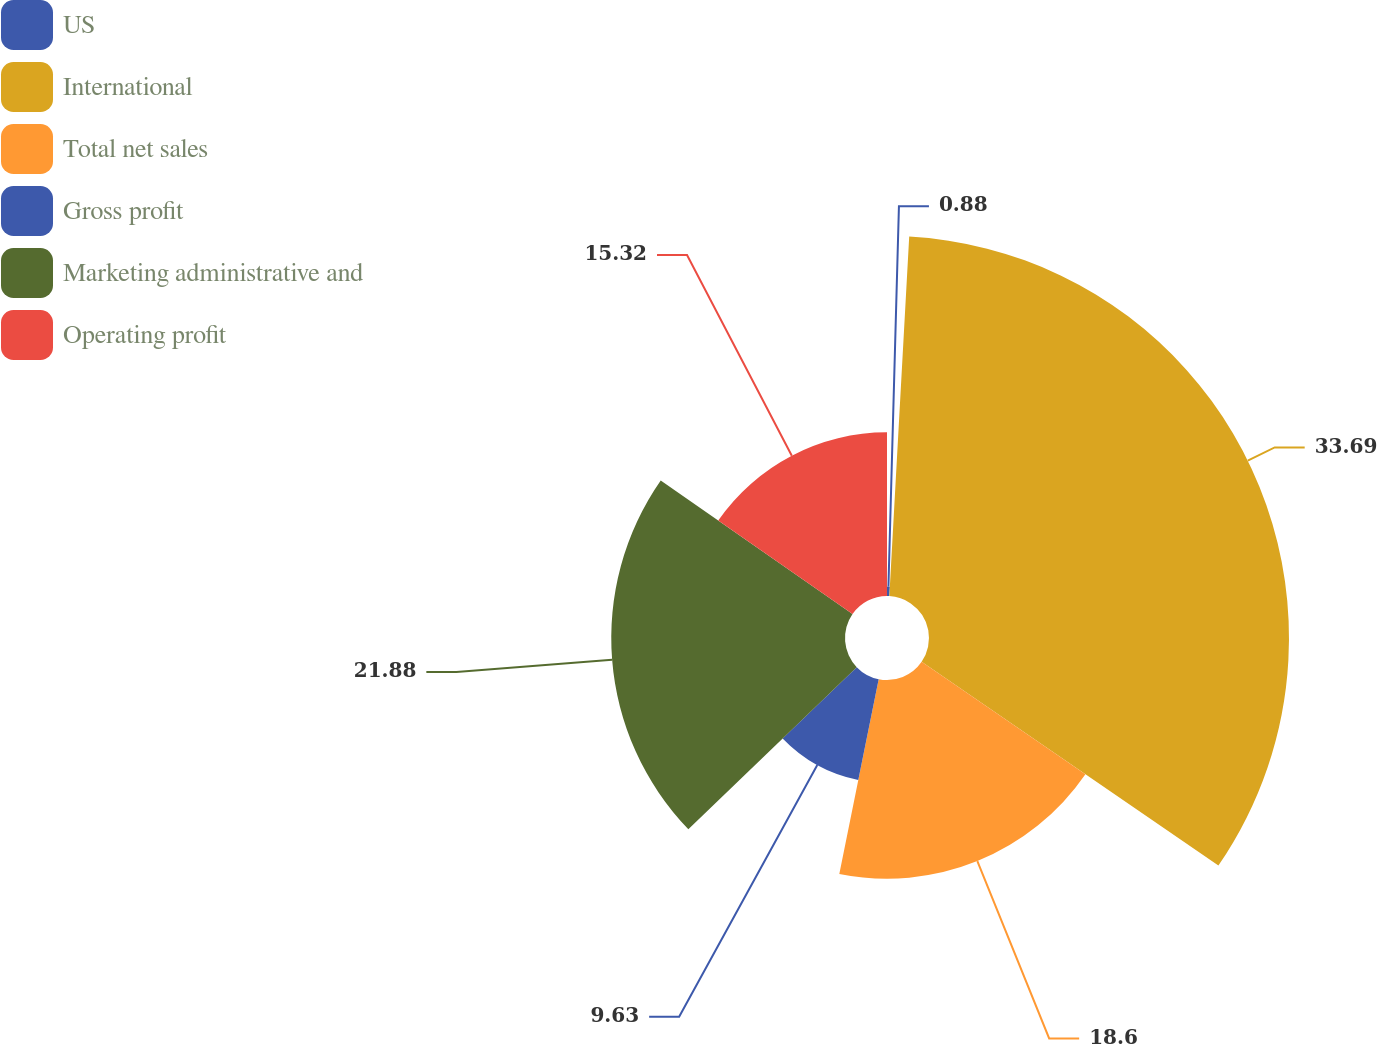<chart> <loc_0><loc_0><loc_500><loc_500><pie_chart><fcel>US<fcel>International<fcel>Total net sales<fcel>Gross profit<fcel>Marketing administrative and<fcel>Operating profit<nl><fcel>0.88%<fcel>33.7%<fcel>18.6%<fcel>9.63%<fcel>21.88%<fcel>15.32%<nl></chart> 